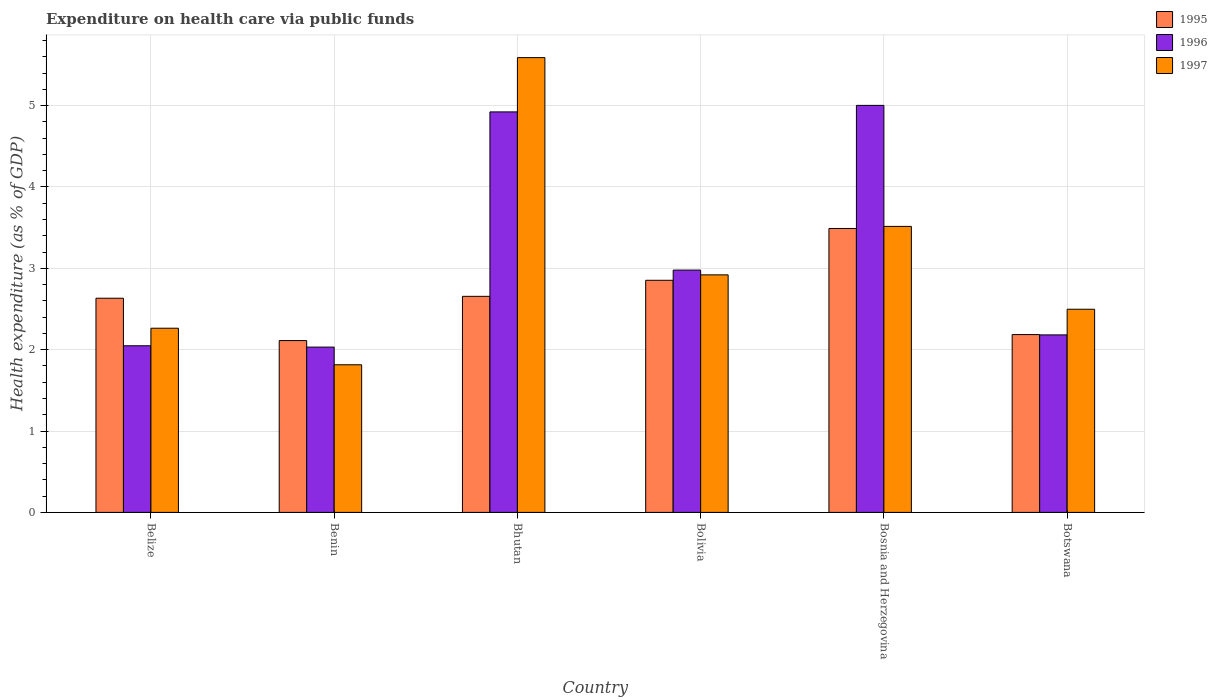How many different coloured bars are there?
Your answer should be very brief. 3. How many groups of bars are there?
Make the answer very short. 6. Are the number of bars per tick equal to the number of legend labels?
Provide a short and direct response. Yes. Are the number of bars on each tick of the X-axis equal?
Your answer should be very brief. Yes. How many bars are there on the 1st tick from the right?
Your answer should be compact. 3. What is the label of the 5th group of bars from the left?
Offer a very short reply. Bosnia and Herzegovina. In how many cases, is the number of bars for a given country not equal to the number of legend labels?
Your response must be concise. 0. What is the expenditure made on health care in 1997 in Bhutan?
Your response must be concise. 5.59. Across all countries, what is the maximum expenditure made on health care in 1997?
Make the answer very short. 5.59. Across all countries, what is the minimum expenditure made on health care in 1996?
Provide a succinct answer. 2.03. In which country was the expenditure made on health care in 1996 maximum?
Keep it short and to the point. Bosnia and Herzegovina. In which country was the expenditure made on health care in 1997 minimum?
Offer a very short reply. Benin. What is the total expenditure made on health care in 1997 in the graph?
Keep it short and to the point. 18.6. What is the difference between the expenditure made on health care in 1995 in Benin and that in Bhutan?
Give a very brief answer. -0.54. What is the difference between the expenditure made on health care in 1996 in Bhutan and the expenditure made on health care in 1995 in Botswana?
Keep it short and to the point. 2.74. What is the average expenditure made on health care in 1997 per country?
Your response must be concise. 3.1. What is the difference between the expenditure made on health care of/in 1996 and expenditure made on health care of/in 1995 in Bhutan?
Provide a short and direct response. 2.27. In how many countries, is the expenditure made on health care in 1997 greater than 3 %?
Your answer should be very brief. 2. What is the ratio of the expenditure made on health care in 1996 in Benin to that in Bolivia?
Your answer should be very brief. 0.68. Is the expenditure made on health care in 1995 in Belize less than that in Bolivia?
Your response must be concise. Yes. Is the difference between the expenditure made on health care in 1996 in Belize and Botswana greater than the difference between the expenditure made on health care in 1995 in Belize and Botswana?
Offer a very short reply. No. What is the difference between the highest and the second highest expenditure made on health care in 1996?
Keep it short and to the point. -1.94. What is the difference between the highest and the lowest expenditure made on health care in 1996?
Provide a succinct answer. 2.97. What does the 1st bar from the right in Belize represents?
Make the answer very short. 1997. Is it the case that in every country, the sum of the expenditure made on health care in 1996 and expenditure made on health care in 1995 is greater than the expenditure made on health care in 1997?
Provide a succinct answer. Yes. Does the graph contain grids?
Your answer should be very brief. Yes. Where does the legend appear in the graph?
Provide a short and direct response. Top right. How are the legend labels stacked?
Provide a succinct answer. Vertical. What is the title of the graph?
Provide a short and direct response. Expenditure on health care via public funds. What is the label or title of the Y-axis?
Provide a succinct answer. Health expenditure (as % of GDP). What is the Health expenditure (as % of GDP) in 1995 in Belize?
Provide a short and direct response. 2.63. What is the Health expenditure (as % of GDP) of 1996 in Belize?
Give a very brief answer. 2.05. What is the Health expenditure (as % of GDP) in 1997 in Belize?
Your answer should be very brief. 2.26. What is the Health expenditure (as % of GDP) in 1995 in Benin?
Offer a terse response. 2.11. What is the Health expenditure (as % of GDP) of 1996 in Benin?
Offer a terse response. 2.03. What is the Health expenditure (as % of GDP) in 1997 in Benin?
Your answer should be compact. 1.81. What is the Health expenditure (as % of GDP) in 1995 in Bhutan?
Make the answer very short. 2.66. What is the Health expenditure (as % of GDP) of 1996 in Bhutan?
Offer a very short reply. 4.92. What is the Health expenditure (as % of GDP) of 1997 in Bhutan?
Provide a succinct answer. 5.59. What is the Health expenditure (as % of GDP) in 1995 in Bolivia?
Provide a succinct answer. 2.85. What is the Health expenditure (as % of GDP) of 1996 in Bolivia?
Your answer should be compact. 2.98. What is the Health expenditure (as % of GDP) in 1997 in Bolivia?
Offer a terse response. 2.92. What is the Health expenditure (as % of GDP) of 1995 in Bosnia and Herzegovina?
Make the answer very short. 3.49. What is the Health expenditure (as % of GDP) in 1996 in Bosnia and Herzegovina?
Keep it short and to the point. 5. What is the Health expenditure (as % of GDP) in 1997 in Bosnia and Herzegovina?
Your answer should be very brief. 3.52. What is the Health expenditure (as % of GDP) in 1995 in Botswana?
Your answer should be compact. 2.19. What is the Health expenditure (as % of GDP) of 1996 in Botswana?
Provide a succinct answer. 2.18. What is the Health expenditure (as % of GDP) in 1997 in Botswana?
Give a very brief answer. 2.5. Across all countries, what is the maximum Health expenditure (as % of GDP) in 1995?
Your answer should be compact. 3.49. Across all countries, what is the maximum Health expenditure (as % of GDP) of 1996?
Provide a short and direct response. 5. Across all countries, what is the maximum Health expenditure (as % of GDP) of 1997?
Provide a short and direct response. 5.59. Across all countries, what is the minimum Health expenditure (as % of GDP) in 1995?
Offer a terse response. 2.11. Across all countries, what is the minimum Health expenditure (as % of GDP) of 1996?
Offer a very short reply. 2.03. Across all countries, what is the minimum Health expenditure (as % of GDP) of 1997?
Your response must be concise. 1.81. What is the total Health expenditure (as % of GDP) in 1995 in the graph?
Offer a terse response. 15.93. What is the total Health expenditure (as % of GDP) of 1996 in the graph?
Offer a very short reply. 19.16. What is the total Health expenditure (as % of GDP) in 1997 in the graph?
Provide a succinct answer. 18.6. What is the difference between the Health expenditure (as % of GDP) in 1995 in Belize and that in Benin?
Keep it short and to the point. 0.52. What is the difference between the Health expenditure (as % of GDP) in 1996 in Belize and that in Benin?
Offer a terse response. 0.02. What is the difference between the Health expenditure (as % of GDP) in 1997 in Belize and that in Benin?
Provide a succinct answer. 0.45. What is the difference between the Health expenditure (as % of GDP) of 1995 in Belize and that in Bhutan?
Provide a succinct answer. -0.02. What is the difference between the Health expenditure (as % of GDP) of 1996 in Belize and that in Bhutan?
Give a very brief answer. -2.87. What is the difference between the Health expenditure (as % of GDP) of 1997 in Belize and that in Bhutan?
Your response must be concise. -3.33. What is the difference between the Health expenditure (as % of GDP) of 1995 in Belize and that in Bolivia?
Ensure brevity in your answer.  -0.22. What is the difference between the Health expenditure (as % of GDP) of 1996 in Belize and that in Bolivia?
Make the answer very short. -0.93. What is the difference between the Health expenditure (as % of GDP) in 1997 in Belize and that in Bolivia?
Offer a very short reply. -0.66. What is the difference between the Health expenditure (as % of GDP) in 1995 in Belize and that in Bosnia and Herzegovina?
Make the answer very short. -0.86. What is the difference between the Health expenditure (as % of GDP) of 1996 in Belize and that in Bosnia and Herzegovina?
Offer a very short reply. -2.95. What is the difference between the Health expenditure (as % of GDP) in 1997 in Belize and that in Bosnia and Herzegovina?
Provide a succinct answer. -1.25. What is the difference between the Health expenditure (as % of GDP) of 1995 in Belize and that in Botswana?
Offer a very short reply. 0.45. What is the difference between the Health expenditure (as % of GDP) in 1996 in Belize and that in Botswana?
Make the answer very short. -0.13. What is the difference between the Health expenditure (as % of GDP) in 1997 in Belize and that in Botswana?
Provide a short and direct response. -0.23. What is the difference between the Health expenditure (as % of GDP) in 1995 in Benin and that in Bhutan?
Offer a terse response. -0.54. What is the difference between the Health expenditure (as % of GDP) in 1996 in Benin and that in Bhutan?
Offer a terse response. -2.89. What is the difference between the Health expenditure (as % of GDP) in 1997 in Benin and that in Bhutan?
Provide a short and direct response. -3.78. What is the difference between the Health expenditure (as % of GDP) in 1995 in Benin and that in Bolivia?
Your answer should be very brief. -0.74. What is the difference between the Health expenditure (as % of GDP) in 1996 in Benin and that in Bolivia?
Provide a succinct answer. -0.95. What is the difference between the Health expenditure (as % of GDP) in 1997 in Benin and that in Bolivia?
Provide a succinct answer. -1.1. What is the difference between the Health expenditure (as % of GDP) in 1995 in Benin and that in Bosnia and Herzegovina?
Provide a succinct answer. -1.38. What is the difference between the Health expenditure (as % of GDP) in 1996 in Benin and that in Bosnia and Herzegovina?
Offer a terse response. -2.97. What is the difference between the Health expenditure (as % of GDP) in 1997 in Benin and that in Bosnia and Herzegovina?
Ensure brevity in your answer.  -1.7. What is the difference between the Health expenditure (as % of GDP) of 1995 in Benin and that in Botswana?
Offer a terse response. -0.07. What is the difference between the Health expenditure (as % of GDP) in 1996 in Benin and that in Botswana?
Keep it short and to the point. -0.15. What is the difference between the Health expenditure (as % of GDP) in 1997 in Benin and that in Botswana?
Provide a succinct answer. -0.68. What is the difference between the Health expenditure (as % of GDP) in 1995 in Bhutan and that in Bolivia?
Provide a short and direct response. -0.2. What is the difference between the Health expenditure (as % of GDP) in 1996 in Bhutan and that in Bolivia?
Provide a short and direct response. 1.94. What is the difference between the Health expenditure (as % of GDP) of 1997 in Bhutan and that in Bolivia?
Provide a short and direct response. 2.67. What is the difference between the Health expenditure (as % of GDP) in 1995 in Bhutan and that in Bosnia and Herzegovina?
Provide a short and direct response. -0.83. What is the difference between the Health expenditure (as % of GDP) of 1996 in Bhutan and that in Bosnia and Herzegovina?
Your answer should be very brief. -0.08. What is the difference between the Health expenditure (as % of GDP) of 1997 in Bhutan and that in Bosnia and Herzegovina?
Make the answer very short. 2.07. What is the difference between the Health expenditure (as % of GDP) of 1995 in Bhutan and that in Botswana?
Provide a short and direct response. 0.47. What is the difference between the Health expenditure (as % of GDP) in 1996 in Bhutan and that in Botswana?
Your answer should be compact. 2.74. What is the difference between the Health expenditure (as % of GDP) of 1997 in Bhutan and that in Botswana?
Provide a succinct answer. 3.09. What is the difference between the Health expenditure (as % of GDP) of 1995 in Bolivia and that in Bosnia and Herzegovina?
Offer a very short reply. -0.64. What is the difference between the Health expenditure (as % of GDP) of 1996 in Bolivia and that in Bosnia and Herzegovina?
Offer a terse response. -2.02. What is the difference between the Health expenditure (as % of GDP) in 1997 in Bolivia and that in Bosnia and Herzegovina?
Keep it short and to the point. -0.6. What is the difference between the Health expenditure (as % of GDP) of 1995 in Bolivia and that in Botswana?
Your response must be concise. 0.67. What is the difference between the Health expenditure (as % of GDP) of 1996 in Bolivia and that in Botswana?
Offer a very short reply. 0.8. What is the difference between the Health expenditure (as % of GDP) in 1997 in Bolivia and that in Botswana?
Your response must be concise. 0.42. What is the difference between the Health expenditure (as % of GDP) in 1995 in Bosnia and Herzegovina and that in Botswana?
Your answer should be compact. 1.3. What is the difference between the Health expenditure (as % of GDP) in 1996 in Bosnia and Herzegovina and that in Botswana?
Keep it short and to the point. 2.82. What is the difference between the Health expenditure (as % of GDP) in 1997 in Bosnia and Herzegovina and that in Botswana?
Keep it short and to the point. 1.02. What is the difference between the Health expenditure (as % of GDP) in 1995 in Belize and the Health expenditure (as % of GDP) in 1996 in Benin?
Give a very brief answer. 0.6. What is the difference between the Health expenditure (as % of GDP) in 1995 in Belize and the Health expenditure (as % of GDP) in 1997 in Benin?
Offer a terse response. 0.82. What is the difference between the Health expenditure (as % of GDP) of 1996 in Belize and the Health expenditure (as % of GDP) of 1997 in Benin?
Give a very brief answer. 0.23. What is the difference between the Health expenditure (as % of GDP) in 1995 in Belize and the Health expenditure (as % of GDP) in 1996 in Bhutan?
Provide a succinct answer. -2.29. What is the difference between the Health expenditure (as % of GDP) in 1995 in Belize and the Health expenditure (as % of GDP) in 1997 in Bhutan?
Ensure brevity in your answer.  -2.96. What is the difference between the Health expenditure (as % of GDP) of 1996 in Belize and the Health expenditure (as % of GDP) of 1997 in Bhutan?
Give a very brief answer. -3.54. What is the difference between the Health expenditure (as % of GDP) of 1995 in Belize and the Health expenditure (as % of GDP) of 1996 in Bolivia?
Your response must be concise. -0.35. What is the difference between the Health expenditure (as % of GDP) of 1995 in Belize and the Health expenditure (as % of GDP) of 1997 in Bolivia?
Keep it short and to the point. -0.29. What is the difference between the Health expenditure (as % of GDP) of 1996 in Belize and the Health expenditure (as % of GDP) of 1997 in Bolivia?
Make the answer very short. -0.87. What is the difference between the Health expenditure (as % of GDP) in 1995 in Belize and the Health expenditure (as % of GDP) in 1996 in Bosnia and Herzegovina?
Your response must be concise. -2.37. What is the difference between the Health expenditure (as % of GDP) in 1995 in Belize and the Health expenditure (as % of GDP) in 1997 in Bosnia and Herzegovina?
Give a very brief answer. -0.88. What is the difference between the Health expenditure (as % of GDP) of 1996 in Belize and the Health expenditure (as % of GDP) of 1997 in Bosnia and Herzegovina?
Give a very brief answer. -1.47. What is the difference between the Health expenditure (as % of GDP) of 1995 in Belize and the Health expenditure (as % of GDP) of 1996 in Botswana?
Your response must be concise. 0.45. What is the difference between the Health expenditure (as % of GDP) of 1995 in Belize and the Health expenditure (as % of GDP) of 1997 in Botswana?
Your answer should be very brief. 0.14. What is the difference between the Health expenditure (as % of GDP) of 1996 in Belize and the Health expenditure (as % of GDP) of 1997 in Botswana?
Your answer should be compact. -0.45. What is the difference between the Health expenditure (as % of GDP) of 1995 in Benin and the Health expenditure (as % of GDP) of 1996 in Bhutan?
Give a very brief answer. -2.81. What is the difference between the Health expenditure (as % of GDP) of 1995 in Benin and the Health expenditure (as % of GDP) of 1997 in Bhutan?
Your response must be concise. -3.48. What is the difference between the Health expenditure (as % of GDP) in 1996 in Benin and the Health expenditure (as % of GDP) in 1997 in Bhutan?
Give a very brief answer. -3.56. What is the difference between the Health expenditure (as % of GDP) in 1995 in Benin and the Health expenditure (as % of GDP) in 1996 in Bolivia?
Your answer should be very brief. -0.87. What is the difference between the Health expenditure (as % of GDP) in 1995 in Benin and the Health expenditure (as % of GDP) in 1997 in Bolivia?
Make the answer very short. -0.81. What is the difference between the Health expenditure (as % of GDP) in 1996 in Benin and the Health expenditure (as % of GDP) in 1997 in Bolivia?
Keep it short and to the point. -0.89. What is the difference between the Health expenditure (as % of GDP) of 1995 in Benin and the Health expenditure (as % of GDP) of 1996 in Bosnia and Herzegovina?
Your response must be concise. -2.89. What is the difference between the Health expenditure (as % of GDP) of 1995 in Benin and the Health expenditure (as % of GDP) of 1997 in Bosnia and Herzegovina?
Offer a terse response. -1.4. What is the difference between the Health expenditure (as % of GDP) of 1996 in Benin and the Health expenditure (as % of GDP) of 1997 in Bosnia and Herzegovina?
Offer a terse response. -1.48. What is the difference between the Health expenditure (as % of GDP) in 1995 in Benin and the Health expenditure (as % of GDP) in 1996 in Botswana?
Your response must be concise. -0.07. What is the difference between the Health expenditure (as % of GDP) of 1995 in Benin and the Health expenditure (as % of GDP) of 1997 in Botswana?
Provide a short and direct response. -0.39. What is the difference between the Health expenditure (as % of GDP) of 1996 in Benin and the Health expenditure (as % of GDP) of 1997 in Botswana?
Provide a short and direct response. -0.47. What is the difference between the Health expenditure (as % of GDP) in 1995 in Bhutan and the Health expenditure (as % of GDP) in 1996 in Bolivia?
Provide a succinct answer. -0.32. What is the difference between the Health expenditure (as % of GDP) in 1995 in Bhutan and the Health expenditure (as % of GDP) in 1997 in Bolivia?
Your response must be concise. -0.26. What is the difference between the Health expenditure (as % of GDP) in 1996 in Bhutan and the Health expenditure (as % of GDP) in 1997 in Bolivia?
Your answer should be compact. 2. What is the difference between the Health expenditure (as % of GDP) of 1995 in Bhutan and the Health expenditure (as % of GDP) of 1996 in Bosnia and Herzegovina?
Keep it short and to the point. -2.35. What is the difference between the Health expenditure (as % of GDP) of 1995 in Bhutan and the Health expenditure (as % of GDP) of 1997 in Bosnia and Herzegovina?
Ensure brevity in your answer.  -0.86. What is the difference between the Health expenditure (as % of GDP) in 1996 in Bhutan and the Health expenditure (as % of GDP) in 1997 in Bosnia and Herzegovina?
Keep it short and to the point. 1.41. What is the difference between the Health expenditure (as % of GDP) of 1995 in Bhutan and the Health expenditure (as % of GDP) of 1996 in Botswana?
Make the answer very short. 0.47. What is the difference between the Health expenditure (as % of GDP) of 1995 in Bhutan and the Health expenditure (as % of GDP) of 1997 in Botswana?
Ensure brevity in your answer.  0.16. What is the difference between the Health expenditure (as % of GDP) of 1996 in Bhutan and the Health expenditure (as % of GDP) of 1997 in Botswana?
Keep it short and to the point. 2.43. What is the difference between the Health expenditure (as % of GDP) of 1995 in Bolivia and the Health expenditure (as % of GDP) of 1996 in Bosnia and Herzegovina?
Make the answer very short. -2.15. What is the difference between the Health expenditure (as % of GDP) of 1995 in Bolivia and the Health expenditure (as % of GDP) of 1997 in Bosnia and Herzegovina?
Your answer should be compact. -0.66. What is the difference between the Health expenditure (as % of GDP) of 1996 in Bolivia and the Health expenditure (as % of GDP) of 1997 in Bosnia and Herzegovina?
Your answer should be very brief. -0.54. What is the difference between the Health expenditure (as % of GDP) of 1995 in Bolivia and the Health expenditure (as % of GDP) of 1996 in Botswana?
Provide a succinct answer. 0.67. What is the difference between the Health expenditure (as % of GDP) in 1995 in Bolivia and the Health expenditure (as % of GDP) in 1997 in Botswana?
Offer a terse response. 0.36. What is the difference between the Health expenditure (as % of GDP) in 1996 in Bolivia and the Health expenditure (as % of GDP) in 1997 in Botswana?
Give a very brief answer. 0.48. What is the difference between the Health expenditure (as % of GDP) in 1995 in Bosnia and Herzegovina and the Health expenditure (as % of GDP) in 1996 in Botswana?
Offer a very short reply. 1.31. What is the difference between the Health expenditure (as % of GDP) of 1996 in Bosnia and Herzegovina and the Health expenditure (as % of GDP) of 1997 in Botswana?
Provide a succinct answer. 2.51. What is the average Health expenditure (as % of GDP) in 1995 per country?
Offer a terse response. 2.65. What is the average Health expenditure (as % of GDP) in 1996 per country?
Your answer should be compact. 3.19. What is the average Health expenditure (as % of GDP) in 1997 per country?
Give a very brief answer. 3.1. What is the difference between the Health expenditure (as % of GDP) of 1995 and Health expenditure (as % of GDP) of 1996 in Belize?
Make the answer very short. 0.58. What is the difference between the Health expenditure (as % of GDP) in 1995 and Health expenditure (as % of GDP) in 1997 in Belize?
Provide a short and direct response. 0.37. What is the difference between the Health expenditure (as % of GDP) in 1996 and Health expenditure (as % of GDP) in 1997 in Belize?
Provide a succinct answer. -0.22. What is the difference between the Health expenditure (as % of GDP) of 1995 and Health expenditure (as % of GDP) of 1996 in Benin?
Provide a succinct answer. 0.08. What is the difference between the Health expenditure (as % of GDP) in 1995 and Health expenditure (as % of GDP) in 1997 in Benin?
Offer a terse response. 0.3. What is the difference between the Health expenditure (as % of GDP) of 1996 and Health expenditure (as % of GDP) of 1997 in Benin?
Offer a terse response. 0.22. What is the difference between the Health expenditure (as % of GDP) of 1995 and Health expenditure (as % of GDP) of 1996 in Bhutan?
Offer a very short reply. -2.27. What is the difference between the Health expenditure (as % of GDP) of 1995 and Health expenditure (as % of GDP) of 1997 in Bhutan?
Offer a very short reply. -2.93. What is the difference between the Health expenditure (as % of GDP) in 1996 and Health expenditure (as % of GDP) in 1997 in Bhutan?
Keep it short and to the point. -0.67. What is the difference between the Health expenditure (as % of GDP) in 1995 and Health expenditure (as % of GDP) in 1996 in Bolivia?
Provide a succinct answer. -0.13. What is the difference between the Health expenditure (as % of GDP) of 1995 and Health expenditure (as % of GDP) of 1997 in Bolivia?
Offer a terse response. -0.07. What is the difference between the Health expenditure (as % of GDP) in 1996 and Health expenditure (as % of GDP) in 1997 in Bolivia?
Give a very brief answer. 0.06. What is the difference between the Health expenditure (as % of GDP) in 1995 and Health expenditure (as % of GDP) in 1996 in Bosnia and Herzegovina?
Your response must be concise. -1.51. What is the difference between the Health expenditure (as % of GDP) of 1995 and Health expenditure (as % of GDP) of 1997 in Bosnia and Herzegovina?
Ensure brevity in your answer.  -0.03. What is the difference between the Health expenditure (as % of GDP) in 1996 and Health expenditure (as % of GDP) in 1997 in Bosnia and Herzegovina?
Offer a very short reply. 1.49. What is the difference between the Health expenditure (as % of GDP) in 1995 and Health expenditure (as % of GDP) in 1996 in Botswana?
Your answer should be very brief. 0. What is the difference between the Health expenditure (as % of GDP) in 1995 and Health expenditure (as % of GDP) in 1997 in Botswana?
Offer a very short reply. -0.31. What is the difference between the Health expenditure (as % of GDP) in 1996 and Health expenditure (as % of GDP) in 1997 in Botswana?
Provide a succinct answer. -0.32. What is the ratio of the Health expenditure (as % of GDP) of 1995 in Belize to that in Benin?
Offer a terse response. 1.25. What is the ratio of the Health expenditure (as % of GDP) of 1996 in Belize to that in Benin?
Offer a terse response. 1.01. What is the ratio of the Health expenditure (as % of GDP) in 1997 in Belize to that in Benin?
Offer a terse response. 1.25. What is the ratio of the Health expenditure (as % of GDP) in 1996 in Belize to that in Bhutan?
Ensure brevity in your answer.  0.42. What is the ratio of the Health expenditure (as % of GDP) of 1997 in Belize to that in Bhutan?
Provide a short and direct response. 0.41. What is the ratio of the Health expenditure (as % of GDP) in 1995 in Belize to that in Bolivia?
Offer a terse response. 0.92. What is the ratio of the Health expenditure (as % of GDP) in 1996 in Belize to that in Bolivia?
Give a very brief answer. 0.69. What is the ratio of the Health expenditure (as % of GDP) in 1997 in Belize to that in Bolivia?
Your response must be concise. 0.78. What is the ratio of the Health expenditure (as % of GDP) of 1995 in Belize to that in Bosnia and Herzegovina?
Give a very brief answer. 0.75. What is the ratio of the Health expenditure (as % of GDP) of 1996 in Belize to that in Bosnia and Herzegovina?
Offer a terse response. 0.41. What is the ratio of the Health expenditure (as % of GDP) of 1997 in Belize to that in Bosnia and Herzegovina?
Your answer should be very brief. 0.64. What is the ratio of the Health expenditure (as % of GDP) in 1995 in Belize to that in Botswana?
Your answer should be compact. 1.2. What is the ratio of the Health expenditure (as % of GDP) in 1996 in Belize to that in Botswana?
Provide a short and direct response. 0.94. What is the ratio of the Health expenditure (as % of GDP) of 1997 in Belize to that in Botswana?
Make the answer very short. 0.91. What is the ratio of the Health expenditure (as % of GDP) of 1995 in Benin to that in Bhutan?
Keep it short and to the point. 0.8. What is the ratio of the Health expenditure (as % of GDP) in 1996 in Benin to that in Bhutan?
Give a very brief answer. 0.41. What is the ratio of the Health expenditure (as % of GDP) in 1997 in Benin to that in Bhutan?
Your answer should be very brief. 0.32. What is the ratio of the Health expenditure (as % of GDP) in 1995 in Benin to that in Bolivia?
Your answer should be compact. 0.74. What is the ratio of the Health expenditure (as % of GDP) of 1996 in Benin to that in Bolivia?
Your response must be concise. 0.68. What is the ratio of the Health expenditure (as % of GDP) in 1997 in Benin to that in Bolivia?
Provide a short and direct response. 0.62. What is the ratio of the Health expenditure (as % of GDP) in 1995 in Benin to that in Bosnia and Herzegovina?
Provide a short and direct response. 0.61. What is the ratio of the Health expenditure (as % of GDP) of 1996 in Benin to that in Bosnia and Herzegovina?
Provide a short and direct response. 0.41. What is the ratio of the Health expenditure (as % of GDP) in 1997 in Benin to that in Bosnia and Herzegovina?
Give a very brief answer. 0.52. What is the ratio of the Health expenditure (as % of GDP) in 1995 in Benin to that in Botswana?
Give a very brief answer. 0.97. What is the ratio of the Health expenditure (as % of GDP) of 1996 in Benin to that in Botswana?
Offer a very short reply. 0.93. What is the ratio of the Health expenditure (as % of GDP) in 1997 in Benin to that in Botswana?
Offer a very short reply. 0.73. What is the ratio of the Health expenditure (as % of GDP) in 1995 in Bhutan to that in Bolivia?
Your answer should be very brief. 0.93. What is the ratio of the Health expenditure (as % of GDP) in 1996 in Bhutan to that in Bolivia?
Your response must be concise. 1.65. What is the ratio of the Health expenditure (as % of GDP) of 1997 in Bhutan to that in Bolivia?
Ensure brevity in your answer.  1.91. What is the ratio of the Health expenditure (as % of GDP) of 1995 in Bhutan to that in Bosnia and Herzegovina?
Offer a very short reply. 0.76. What is the ratio of the Health expenditure (as % of GDP) in 1996 in Bhutan to that in Bosnia and Herzegovina?
Provide a succinct answer. 0.98. What is the ratio of the Health expenditure (as % of GDP) of 1997 in Bhutan to that in Bosnia and Herzegovina?
Your answer should be compact. 1.59. What is the ratio of the Health expenditure (as % of GDP) in 1995 in Bhutan to that in Botswana?
Provide a succinct answer. 1.22. What is the ratio of the Health expenditure (as % of GDP) of 1996 in Bhutan to that in Botswana?
Offer a terse response. 2.26. What is the ratio of the Health expenditure (as % of GDP) in 1997 in Bhutan to that in Botswana?
Your answer should be very brief. 2.24. What is the ratio of the Health expenditure (as % of GDP) in 1995 in Bolivia to that in Bosnia and Herzegovina?
Give a very brief answer. 0.82. What is the ratio of the Health expenditure (as % of GDP) in 1996 in Bolivia to that in Bosnia and Herzegovina?
Offer a terse response. 0.6. What is the ratio of the Health expenditure (as % of GDP) in 1997 in Bolivia to that in Bosnia and Herzegovina?
Offer a very short reply. 0.83. What is the ratio of the Health expenditure (as % of GDP) in 1995 in Bolivia to that in Botswana?
Give a very brief answer. 1.31. What is the ratio of the Health expenditure (as % of GDP) in 1996 in Bolivia to that in Botswana?
Your answer should be very brief. 1.37. What is the ratio of the Health expenditure (as % of GDP) of 1997 in Bolivia to that in Botswana?
Offer a terse response. 1.17. What is the ratio of the Health expenditure (as % of GDP) of 1995 in Bosnia and Herzegovina to that in Botswana?
Offer a very short reply. 1.6. What is the ratio of the Health expenditure (as % of GDP) in 1996 in Bosnia and Herzegovina to that in Botswana?
Your answer should be compact. 2.29. What is the ratio of the Health expenditure (as % of GDP) of 1997 in Bosnia and Herzegovina to that in Botswana?
Your answer should be very brief. 1.41. What is the difference between the highest and the second highest Health expenditure (as % of GDP) of 1995?
Your answer should be compact. 0.64. What is the difference between the highest and the second highest Health expenditure (as % of GDP) of 1996?
Offer a terse response. 0.08. What is the difference between the highest and the second highest Health expenditure (as % of GDP) of 1997?
Offer a terse response. 2.07. What is the difference between the highest and the lowest Health expenditure (as % of GDP) in 1995?
Provide a succinct answer. 1.38. What is the difference between the highest and the lowest Health expenditure (as % of GDP) of 1996?
Ensure brevity in your answer.  2.97. What is the difference between the highest and the lowest Health expenditure (as % of GDP) in 1997?
Provide a succinct answer. 3.78. 